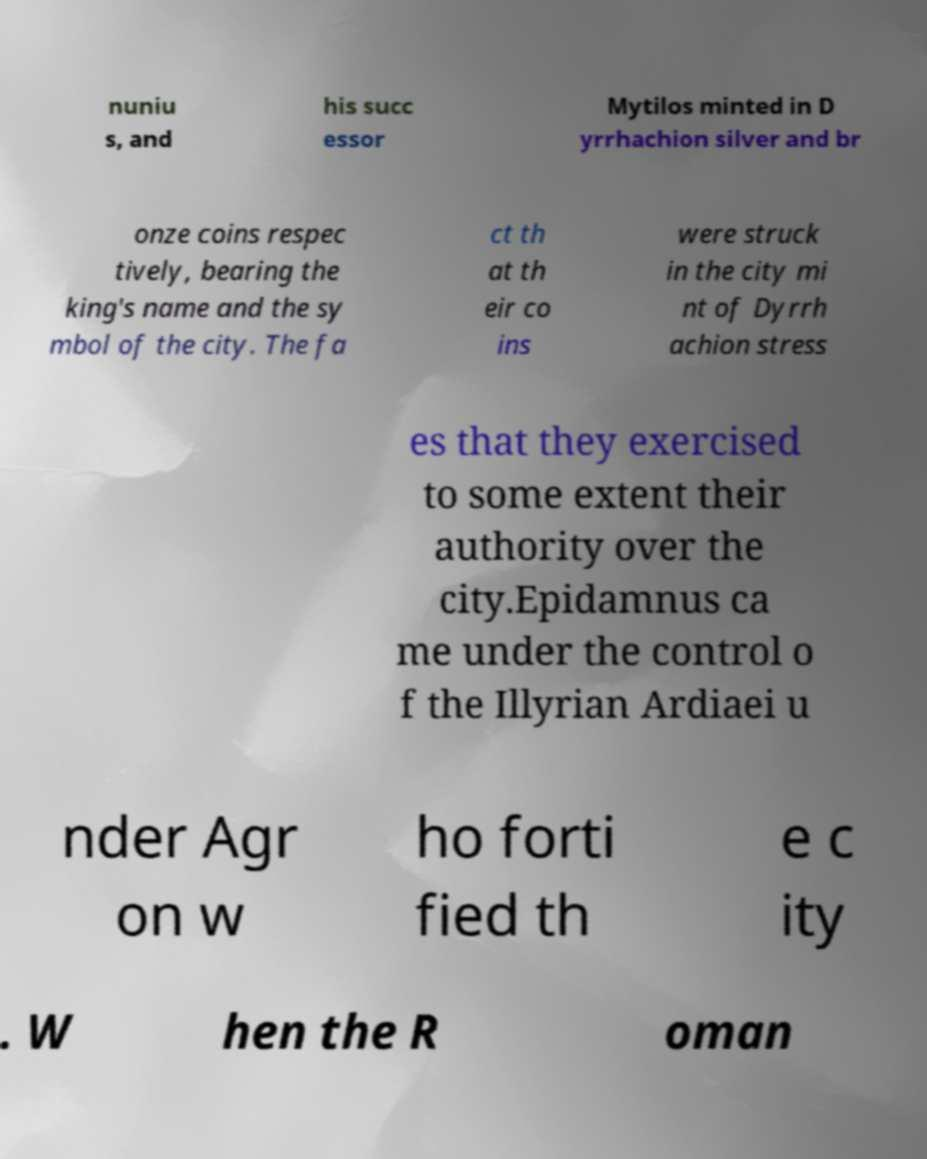Please read and relay the text visible in this image. What does it say? nuniu s, and his succ essor Mytilos minted in D yrrhachion silver and br onze coins respec tively, bearing the king's name and the sy mbol of the city. The fa ct th at th eir co ins were struck in the city mi nt of Dyrrh achion stress es that they exercised to some extent their authority over the city.Epidamnus ca me under the control o f the Illyrian Ardiaei u nder Agr on w ho forti fied th e c ity . W hen the R oman 